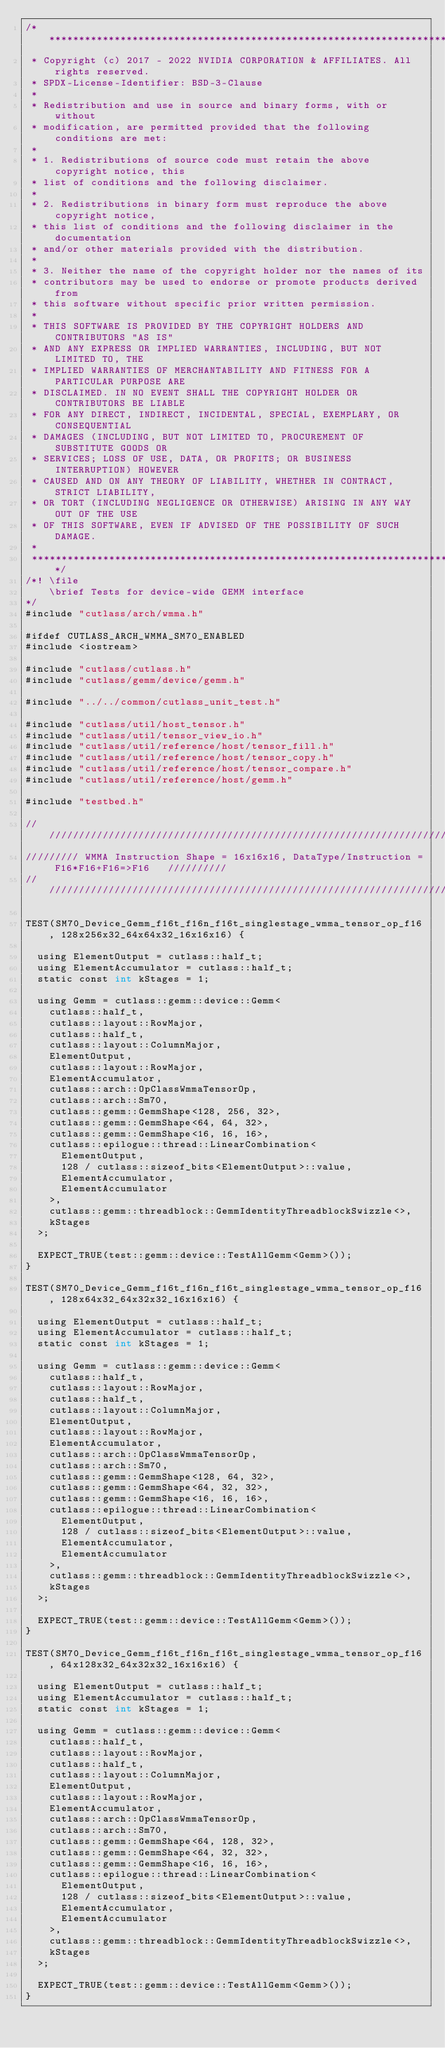Convert code to text. <code><loc_0><loc_0><loc_500><loc_500><_Cuda_>/***************************************************************************************************
 * Copyright (c) 2017 - 2022 NVIDIA CORPORATION & AFFILIATES. All rights reserved.
 * SPDX-License-Identifier: BSD-3-Clause
 *
 * Redistribution and use in source and binary forms, with or without
 * modification, are permitted provided that the following conditions are met:
 *
 * 1. Redistributions of source code must retain the above copyright notice, this
 * list of conditions and the following disclaimer.
 *
 * 2. Redistributions in binary form must reproduce the above copyright notice,
 * this list of conditions and the following disclaimer in the documentation
 * and/or other materials provided with the distribution.
 *
 * 3. Neither the name of the copyright holder nor the names of its
 * contributors may be used to endorse or promote products derived from
 * this software without specific prior written permission.
 *
 * THIS SOFTWARE IS PROVIDED BY THE COPYRIGHT HOLDERS AND CONTRIBUTORS "AS IS"
 * AND ANY EXPRESS OR IMPLIED WARRANTIES, INCLUDING, BUT NOT LIMITED TO, THE
 * IMPLIED WARRANTIES OF MERCHANTABILITY AND FITNESS FOR A PARTICULAR PURPOSE ARE
 * DISCLAIMED. IN NO EVENT SHALL THE COPYRIGHT HOLDER OR CONTRIBUTORS BE LIABLE
 * FOR ANY DIRECT, INDIRECT, INCIDENTAL, SPECIAL, EXEMPLARY, OR CONSEQUENTIAL
 * DAMAGES (INCLUDING, BUT NOT LIMITED TO, PROCUREMENT OF SUBSTITUTE GOODS OR
 * SERVICES; LOSS OF USE, DATA, OR PROFITS; OR BUSINESS INTERRUPTION) HOWEVER
 * CAUSED AND ON ANY THEORY OF LIABILITY, WHETHER IN CONTRACT, STRICT LIABILITY,
 * OR TORT (INCLUDING NEGLIGENCE OR OTHERWISE) ARISING IN ANY WAY OUT OF THE USE
 * OF THIS SOFTWARE, EVEN IF ADVISED OF THE POSSIBILITY OF SUCH DAMAGE.
 *
 **************************************************************************************************/
/*! \file
    \brief Tests for device-wide GEMM interface
*/
#include "cutlass/arch/wmma.h"

#ifdef CUTLASS_ARCH_WMMA_SM70_ENABLED
#include <iostream>

#include "cutlass/cutlass.h"
#include "cutlass/gemm/device/gemm.h"

#include "../../common/cutlass_unit_test.h"

#include "cutlass/util/host_tensor.h"
#include "cutlass/util/tensor_view_io.h"
#include "cutlass/util/reference/host/tensor_fill.h"
#include "cutlass/util/reference/host/tensor_copy.h"
#include "cutlass/util/reference/host/tensor_compare.h"
#include "cutlass/util/reference/host/gemm.h"

#include "testbed.h"

/////////////////////////////////////////////////////////////////////////////////////////////////
///////// WMMA Instruction Shape = 16x16x16, DataType/Instruction = F16*F16+F16=>F16   //////////
/////////////////////////////////////////////////////////////////////////////////////////////////    

TEST(SM70_Device_Gemm_f16t_f16n_f16t_singlestage_wmma_tensor_op_f16, 128x256x32_64x64x32_16x16x16) {

  using ElementOutput = cutlass::half_t;
  using ElementAccumulator = cutlass::half_t;
  static const int kStages = 1;

  using Gemm = cutlass::gemm::device::Gemm<
    cutlass::half_t,
    cutlass::layout::RowMajor,
    cutlass::half_t,
    cutlass::layout::ColumnMajor,
    ElementOutput,
    cutlass::layout::RowMajor,
    ElementAccumulator,
    cutlass::arch::OpClassWmmaTensorOp,
    cutlass::arch::Sm70,
    cutlass::gemm::GemmShape<128, 256, 32>,
    cutlass::gemm::GemmShape<64, 64, 32>,
    cutlass::gemm::GemmShape<16, 16, 16>,
    cutlass::epilogue::thread::LinearCombination<
      ElementOutput,
      128 / cutlass::sizeof_bits<ElementOutput>::value,
      ElementAccumulator,
      ElementAccumulator
    >,
    cutlass::gemm::threadblock::GemmIdentityThreadblockSwizzle<>,
    kStages
  >;

  EXPECT_TRUE(test::gemm::device::TestAllGemm<Gemm>());
}

TEST(SM70_Device_Gemm_f16t_f16n_f16t_singlestage_wmma_tensor_op_f16, 128x64x32_64x32x32_16x16x16) {

  using ElementOutput = cutlass::half_t;
  using ElementAccumulator = cutlass::half_t;
  static const int kStages = 1;

  using Gemm = cutlass::gemm::device::Gemm<
    cutlass::half_t,
    cutlass::layout::RowMajor,
    cutlass::half_t,
    cutlass::layout::ColumnMajor,
    ElementOutput,
    cutlass::layout::RowMajor,
    ElementAccumulator,
    cutlass::arch::OpClassWmmaTensorOp,
    cutlass::arch::Sm70,
    cutlass::gemm::GemmShape<128, 64, 32>,
    cutlass::gemm::GemmShape<64, 32, 32>,
    cutlass::gemm::GemmShape<16, 16, 16>,
    cutlass::epilogue::thread::LinearCombination<
      ElementOutput,
      128 / cutlass::sizeof_bits<ElementOutput>::value,
      ElementAccumulator,
      ElementAccumulator
    >,
    cutlass::gemm::threadblock::GemmIdentityThreadblockSwizzle<>,
    kStages
  >;

  EXPECT_TRUE(test::gemm::device::TestAllGemm<Gemm>());
}

TEST(SM70_Device_Gemm_f16t_f16n_f16t_singlestage_wmma_tensor_op_f16, 64x128x32_64x32x32_16x16x16) {

  using ElementOutput = cutlass::half_t;
  using ElementAccumulator = cutlass::half_t;
  static const int kStages = 1;

  using Gemm = cutlass::gemm::device::Gemm<
    cutlass::half_t,
    cutlass::layout::RowMajor,
    cutlass::half_t,
    cutlass::layout::ColumnMajor,
    ElementOutput,
    cutlass::layout::RowMajor,
    ElementAccumulator,
    cutlass::arch::OpClassWmmaTensorOp,
    cutlass::arch::Sm70,
    cutlass::gemm::GemmShape<64, 128, 32>,
    cutlass::gemm::GemmShape<64, 32, 32>,
    cutlass::gemm::GemmShape<16, 16, 16>,
    cutlass::epilogue::thread::LinearCombination<
      ElementOutput,
      128 / cutlass::sizeof_bits<ElementOutput>::value,
      ElementAccumulator,
      ElementAccumulator
    >,
    cutlass::gemm::threadblock::GemmIdentityThreadblockSwizzle<>,
    kStages
  >;

  EXPECT_TRUE(test::gemm::device::TestAllGemm<Gemm>());
}

</code> 